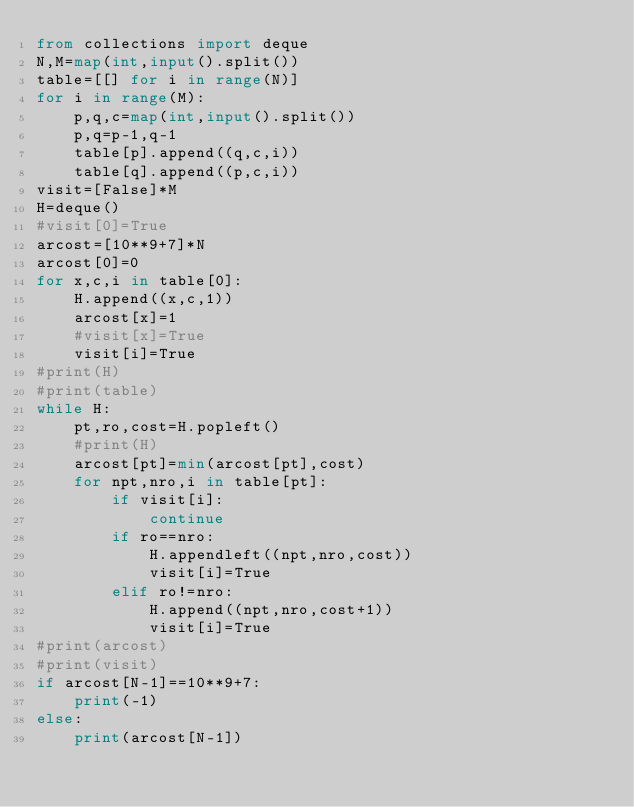Convert code to text. <code><loc_0><loc_0><loc_500><loc_500><_Python_>from collections import deque
N,M=map(int,input().split())
table=[[] for i in range(N)]
for i in range(M):
    p,q,c=map(int,input().split())
    p,q=p-1,q-1
    table[p].append((q,c,i))
    table[q].append((p,c,i))
visit=[False]*M
H=deque()
#visit[0]=True
arcost=[10**9+7]*N
arcost[0]=0
for x,c,i in table[0]:
    H.append((x,c,1))
    arcost[x]=1
    #visit[x]=True
    visit[i]=True
#print(H)
#print(table)
while H:
    pt,ro,cost=H.popleft()
    #print(H)
    arcost[pt]=min(arcost[pt],cost)
    for npt,nro,i in table[pt]:
        if visit[i]:
            continue
        if ro==nro:
            H.appendleft((npt,nro,cost))
            visit[i]=True
        elif ro!=nro:
            H.append((npt,nro,cost+1))
            visit[i]=True
#print(arcost)
#print(visit)
if arcost[N-1]==10**9+7:
    print(-1)
else:
    print(arcost[N-1])
</code> 